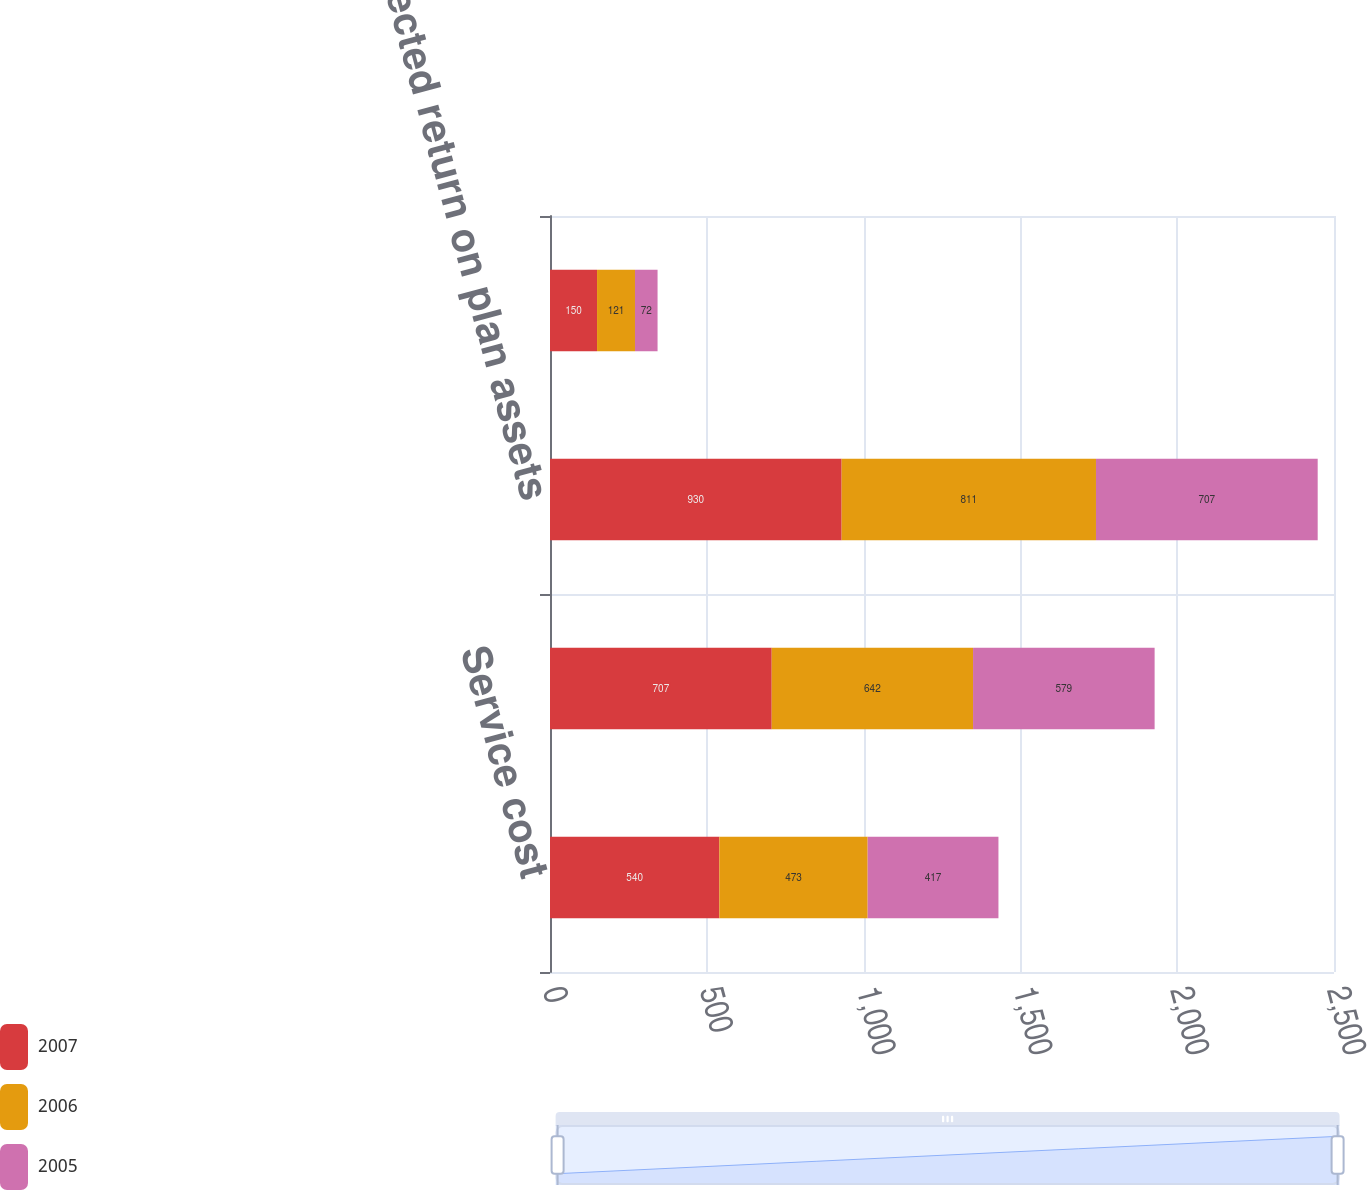Convert chart to OTSL. <chart><loc_0><loc_0><loc_500><loc_500><stacked_bar_chart><ecel><fcel>Service cost<fcel>Interest cost<fcel>Expected return on plan assets<fcel>Recognized actuarial losses<nl><fcel>2007<fcel>540<fcel>707<fcel>930<fcel>150<nl><fcel>2006<fcel>473<fcel>642<fcel>811<fcel>121<nl><fcel>2005<fcel>417<fcel>579<fcel>707<fcel>72<nl></chart> 